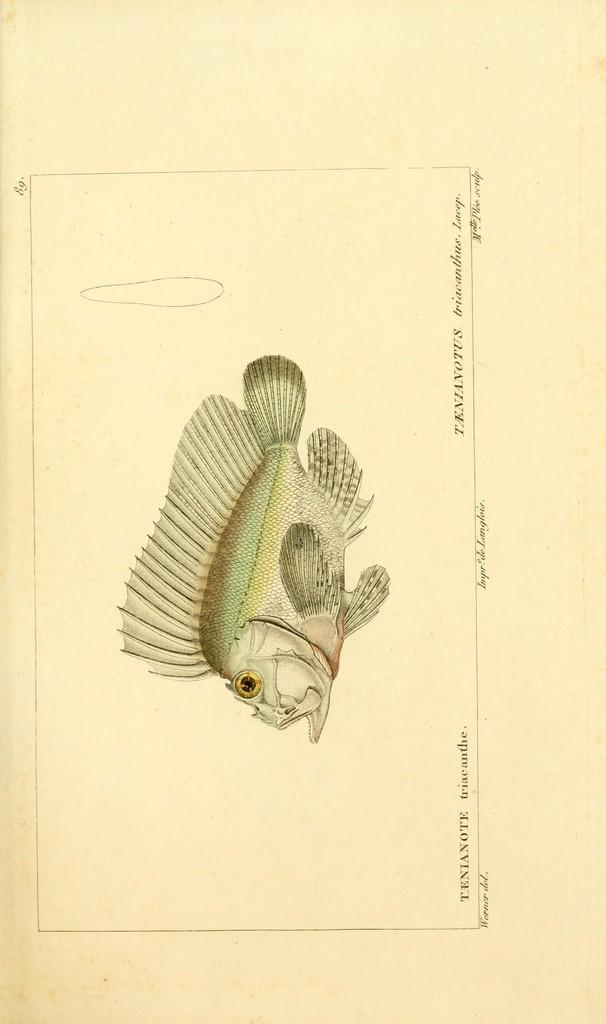What is depicted on the paper in the image? There is a diagram of a fish on a paper in the image. What else can be seen on the paper besides the fish diagram? There are words written on the paper. Are there any numbers visible in the image? Yes, there are two numbers visible in the image. How many tomatoes are on the table in the image? There is no table or tomatoes present in the image; it only features a paper with a fish diagram and words. 